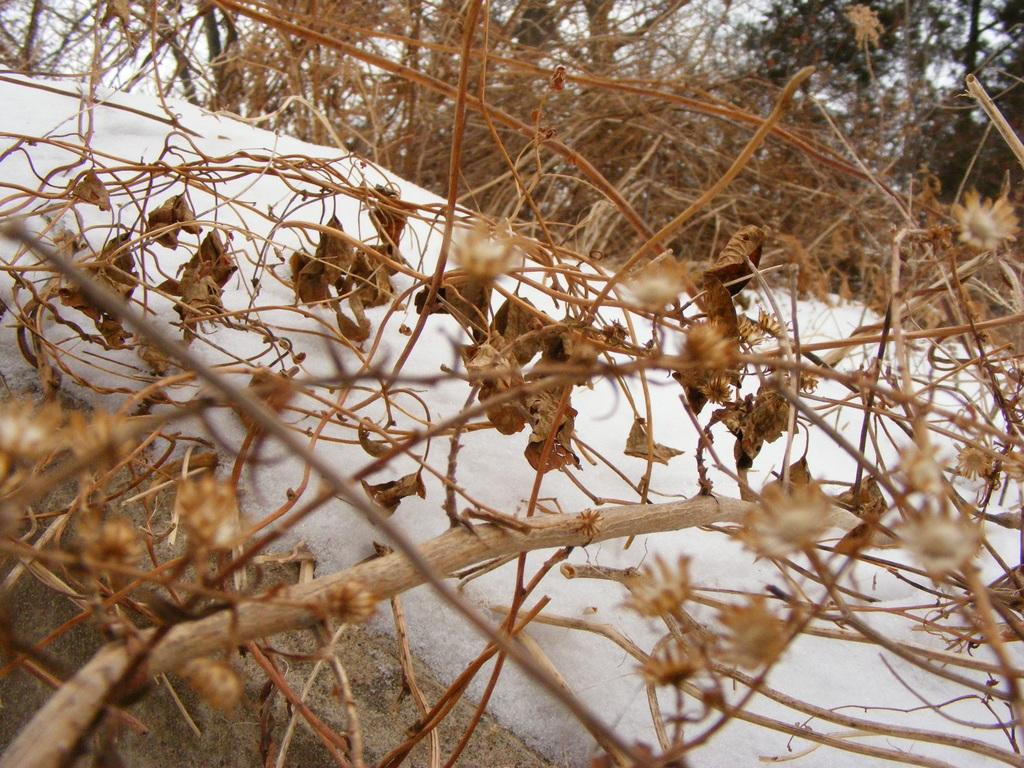What type of weather condition is depicted in the image? The image shows snow on a rock, indicating a cold weather condition. What can be seen above the snow in the image? Dry leaves and dry stems are visible above the snow. Can you describe the vegetation in the image? The vegetation consists of dry leaves and dry stems above the snow. What type of grip can be seen on the flag in the image? There is no flag present in the image, so it is not possible to determine the type of grip on a flag. 